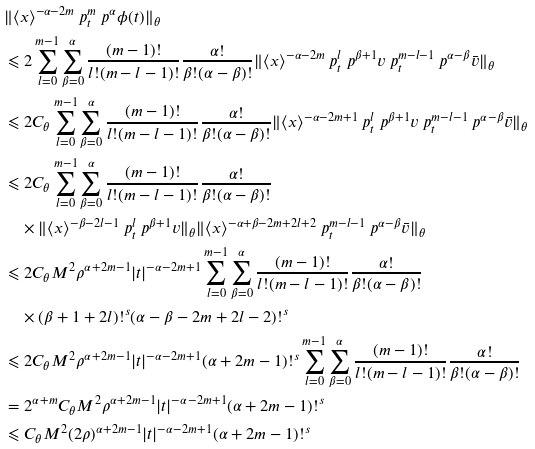<formula> <loc_0><loc_0><loc_500><loc_500>& \| \langle { x } \rangle ^ { - \alpha - 2 m } \ p _ { t } ^ { m } \ p ^ { \alpha } \phi ( t ) \| _ { \theta } \\ & \leqslant 2 \sum _ { l = 0 } ^ { m - 1 } \sum _ { \beta = 0 } ^ { \alpha } \frac { ( m - 1 ) ! } { l ! ( m - l - 1 ) ! } \frac { \alpha ! } { \beta ! ( \alpha - \beta ) ! } \| \langle { x } \rangle ^ { - \alpha - 2 m } \ p _ { t } ^ { l } \ p ^ { \beta + 1 } v \ p _ { t } ^ { m - l - 1 } \ p ^ { \alpha - \beta } \bar { v } \| _ { \theta } \\ & \leqslant 2 C _ { \theta } \sum _ { l = 0 } ^ { m - 1 } \sum _ { \beta = 0 } ^ { \alpha } \frac { ( m - 1 ) ! } { l ! ( m - l - 1 ) ! } \frac { \alpha ! } { \beta ! ( \alpha - \beta ) ! } \| \langle { x } \rangle ^ { - \alpha - 2 m + 1 } \ p _ { t } ^ { l } \ p ^ { \beta + 1 } v \ p _ { t } ^ { m - l - 1 } \ p ^ { \alpha - \beta } \bar { v } \| _ { \theta } \\ & \leqslant 2 C _ { \theta } \sum _ { l = 0 } ^ { m - 1 } \sum _ { \beta = 0 } ^ { \alpha } \frac { ( m - 1 ) ! } { l ! ( m - l - 1 ) ! } \frac { \alpha ! } { \beta ! ( \alpha - \beta ) ! } \\ & \quad \times \| \langle { x } \rangle ^ { - \beta - 2 l - 1 } \ p _ { t } ^ { l } \ p ^ { \beta + 1 } v \| _ { \theta } \| \langle { x } \rangle ^ { - \alpha + \beta - 2 m + 2 l + 2 } \ p _ { t } ^ { m - l - 1 } \ p ^ { \alpha - \beta } \bar { v } \| _ { \theta } \\ & \leqslant 2 C _ { \theta } M ^ { 2 } \rho ^ { \alpha + 2 m - 1 } | { t } | ^ { - \alpha - 2 m + 1 } \sum _ { l = 0 } ^ { m - 1 } \sum _ { \beta = 0 } ^ { \alpha } \frac { ( m - 1 ) ! } { l ! ( m - l - 1 ) ! } \frac { \alpha ! } { \beta ! ( \alpha - \beta ) ! } \\ & \quad \times ( \beta + 1 + 2 l ) ! ^ { s } ( \alpha - \beta - 2 m + 2 l - 2 ) ! ^ { s } \\ & \leqslant 2 C _ { \theta } M ^ { 2 } \rho ^ { \alpha + 2 m - 1 } | { t } | ^ { - \alpha - 2 m + 1 } ( \alpha + 2 m - 1 ) ! ^ { s } \sum _ { l = 0 } ^ { m - 1 } \sum _ { \beta = 0 } ^ { \alpha } \frac { ( m - 1 ) ! } { l ! ( m - l - 1 ) ! } \frac { \alpha ! } { \beta ! ( \alpha - \beta ) ! } \\ & = 2 ^ { \alpha + m } C _ { \theta } M ^ { 2 } \rho ^ { \alpha + 2 m - 1 } | { t } | ^ { - \alpha - 2 m + 1 } ( \alpha + 2 m - 1 ) ! ^ { s } \\ & \leqslant C _ { \theta } M ^ { 2 } ( 2 \rho ) ^ { \alpha + 2 m - 1 } | { t } | ^ { - \alpha - 2 m + 1 } ( \alpha + 2 m - 1 ) ! ^ { s }</formula> 